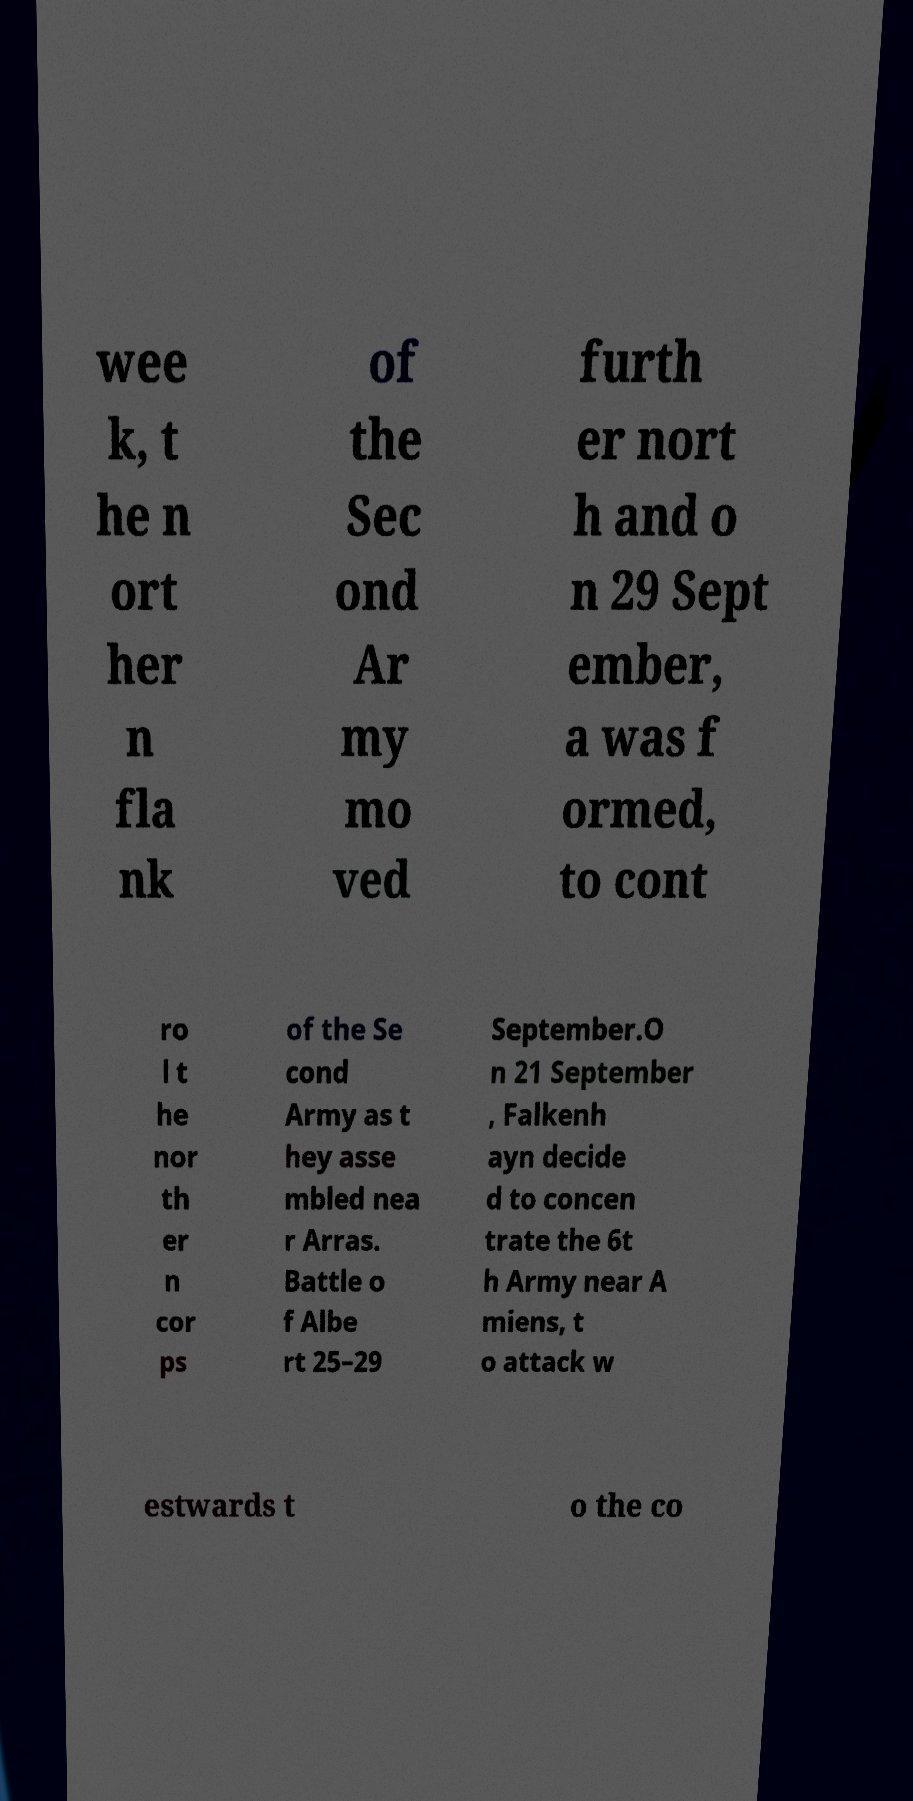There's text embedded in this image that I need extracted. Can you transcribe it verbatim? wee k, t he n ort her n fla nk of the Sec ond Ar my mo ved furth er nort h and o n 29 Sept ember, a was f ormed, to cont ro l t he nor th er n cor ps of the Se cond Army as t hey asse mbled nea r Arras. Battle o f Albe rt 25–29 September.O n 21 September , Falkenh ayn decide d to concen trate the 6t h Army near A miens, t o attack w estwards t o the co 